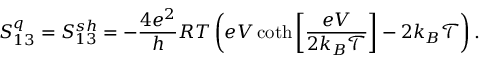<formula> <loc_0><loc_0><loc_500><loc_500>S _ { 1 3 } ^ { q } = { S _ { 1 3 } ^ { s h } } = - \frac { 4 e ^ { 2 } } { h } R T \left ( e V \coth \left [ \frac { e V } { 2 k _ { B } \mathcal { T } } \right ] - 2 k _ { B } \mathcal { T } \right ) .</formula> 